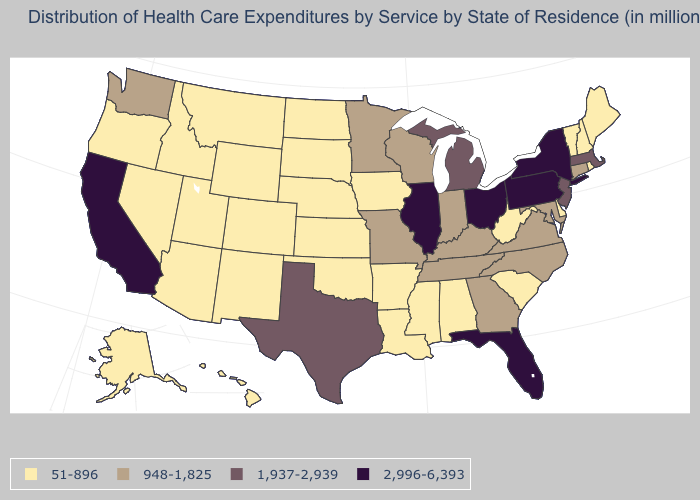What is the lowest value in the USA?
Be succinct. 51-896. Name the states that have a value in the range 51-896?
Quick response, please. Alabama, Alaska, Arizona, Arkansas, Colorado, Delaware, Hawaii, Idaho, Iowa, Kansas, Louisiana, Maine, Mississippi, Montana, Nebraska, Nevada, New Hampshire, New Mexico, North Dakota, Oklahoma, Oregon, Rhode Island, South Carolina, South Dakota, Utah, Vermont, West Virginia, Wyoming. Does Connecticut have the same value as Washington?
Quick response, please. Yes. Is the legend a continuous bar?
Answer briefly. No. What is the value of Kentucky?
Keep it brief. 948-1,825. What is the highest value in states that border North Carolina?
Answer briefly. 948-1,825. What is the lowest value in the Northeast?
Quick response, please. 51-896. Name the states that have a value in the range 948-1,825?
Short answer required. Connecticut, Georgia, Indiana, Kentucky, Maryland, Minnesota, Missouri, North Carolina, Tennessee, Virginia, Washington, Wisconsin. Does Maine have the lowest value in the Northeast?
Answer briefly. Yes. Does Utah have a higher value than Georgia?
Answer briefly. No. Does Indiana have a higher value than Louisiana?
Answer briefly. Yes. Does the map have missing data?
Quick response, please. No. What is the value of West Virginia?
Quick response, please. 51-896. Which states hav the highest value in the West?
Short answer required. California. Does Arizona have a higher value than Massachusetts?
Answer briefly. No. 